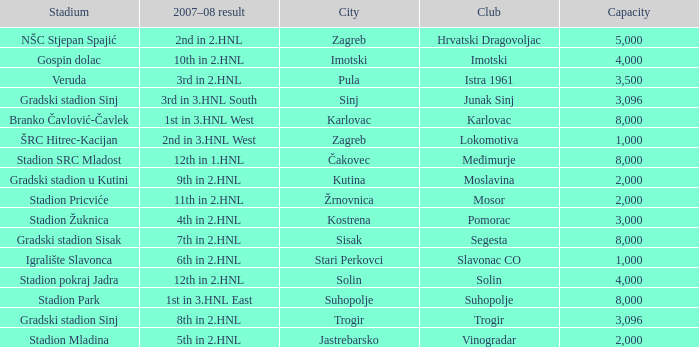What stadium has kutina as the city? Gradski stadion u Kutini. 